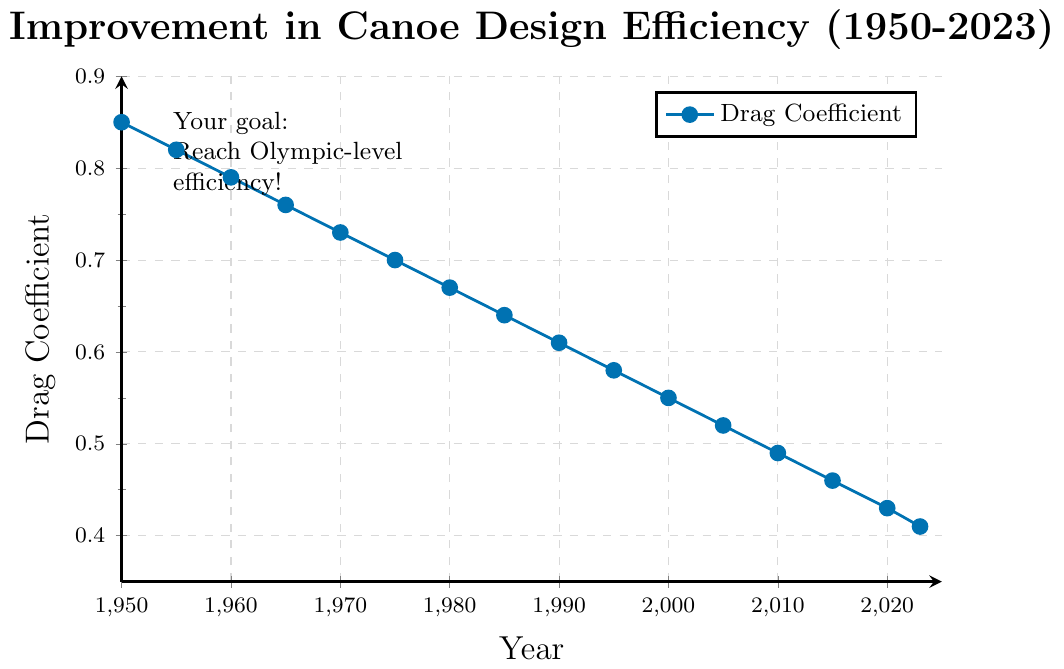What is the initial drag coefficient for 1950? The figure shows the drag coefficient on the y-axis over the years on the x-axis. By locating the year 1950 on the x-axis and drawing a line upwards to the curve, we find the drag coefficient is 0.85.
Answer: 0.85 How much has the drag coefficient decreased from 1950 to 2023? We need to subtract the drag coefficient for 2023 from that for 1950: 0.85 - 0.41 = 0.44
Answer: 0.44 What is the average drag coefficient from 2000 to 2023? Find the drag coefficients for the years 2000, 2005, 2010, 2015, 2020, and 2023, then calculate the average: (0.55 + 0.52 + 0.49 + 0.46 + 0.43 + 0.41) / 6 = 2.86 / 6 = 0.4767
Answer: 0.4767 In which decade did the drag coefficient decrease the most? Compare the differences in drag coefficients for each decade: 
1950s: 0.85 to 0.79 (0.06), 
1960s: 0.79 to 0.73 (0.06), 
1970s: 0.73 to 0.67 (0.06), 
1980s: 0.67 to 0.61 (0.06), 
1990s: 0.61 to 0.55 (0.06), 
2000s: 0.55 to 0.49 (0.06), 
2010s: 0.49 to 0.43 (0.06), 
2020s: 0.43 to 0.41 (0.02).
Each decade decrease is the same, except 2020s.
Answer: 1950s, 1960s, 1970s, 1980s, 1990s, 2000s, 2010s Between which two consecutive 5-year periods did the drag coefficient drop the least? Calculate the drag coefficient drop between each 5-year period:
1950-1955: 0.85 to 0.82 (0.03),
1955-1960: 0.82 to 0.79 (0.03),
1960-1965: 0.79 to 0.76 (0.03),
1965-1970: 0.76 to 0.73 (0.03),
1970-1975: 0.73 to 0.70 (0.03),
1975-1980: 0.70 to 0.67 (0.03),
1980-1985: 0.67 to 0.64 (0.03),
1985-1990: 0.64 to 0.61 (0.03),
1990-1995: 0.61 to 0.58 (0.03),
1995-2000: 0.58 to 0.55 (0.03),
2000-2005: 0.55 to 0.52 (0.03),
2005-2010: 0.52 to 0.49 (0.03),
2010-2015: 0.49 to 0.46 (0.03),
2015-2020: 0.46 to 0.43 (0.03),
2020-2023: 0.43 to 0.41 (0.02). 
2020-2023 is the least.
Answer: 2020 to 2023 What is the trend in the drag coefficient over the years? Observing the plot from 1950 to 2023, the drag coefficient consistently decreases. This visually represents an improvement in canoe design efficiency over these years.
Answer: Decreasing Which year shows a drag coefficient of 0.58? Locate the drag coefficient value of 0.58 on the y-axis, then align it horizontally with the x-axis year. The plot shows 1995.
Answer: 1995 How does the drag coefficient in 1980 compare to that in 1990? The plot shows the drag coefficient in 1980 is 0.67, and in 1990 it is 0.61. Comparing the two, 0.67 is greater than 0.61.
Answer: Greater By how much did the drag coefficient change between 1975 and 1985? Find the drag coefficients for 1975 and 1985 and subtract them: 0.70 - 0.64 = 0.06
Answer: 0.06 What visual element emphasizes the goal in the figure? The figure contains a text box "Your goal: Reach Olympic-level efficiency!" placed at the top-left, which stands out due to its positioning and font style.
Answer: Text box 